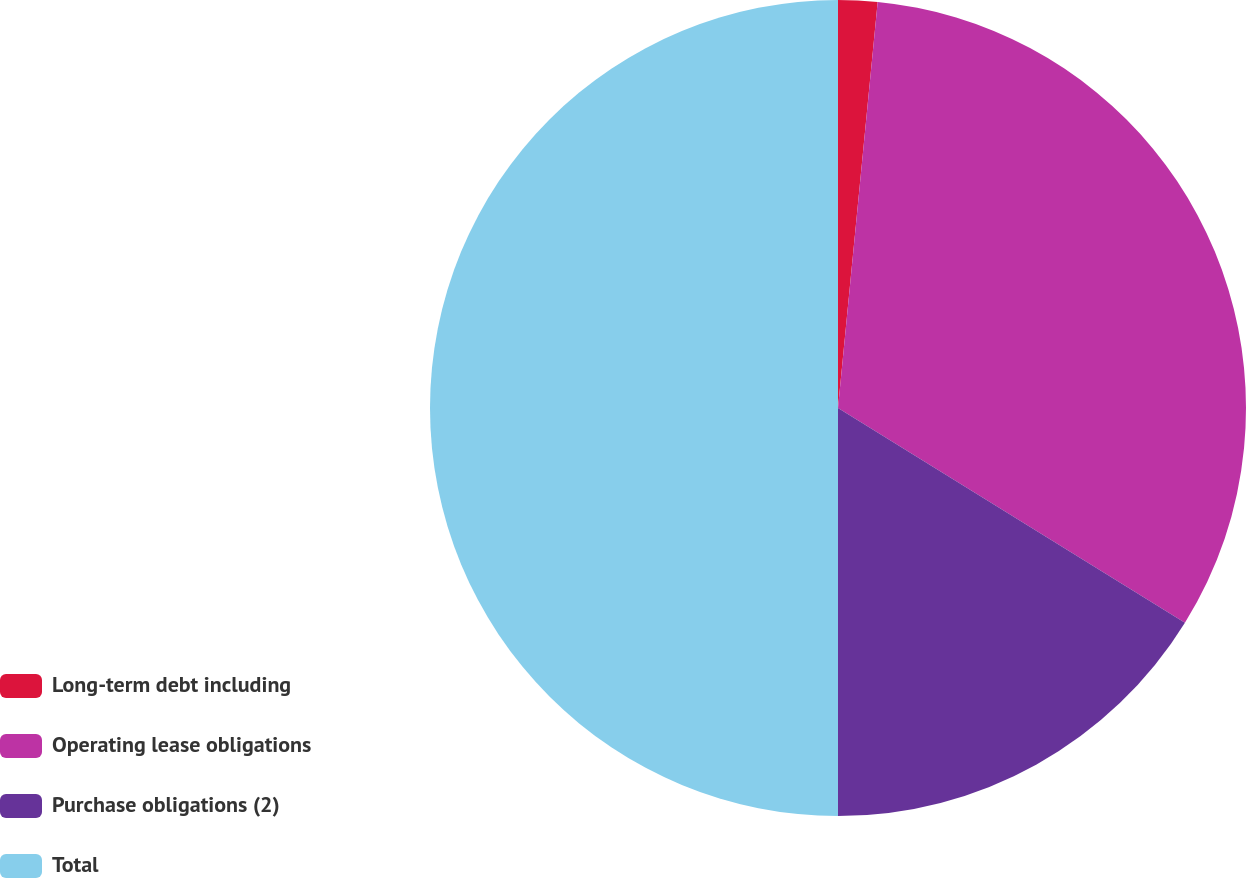Convert chart. <chart><loc_0><loc_0><loc_500><loc_500><pie_chart><fcel>Long-term debt including<fcel>Operating lease obligations<fcel>Purchase obligations (2)<fcel>Total<nl><fcel>1.55%<fcel>32.27%<fcel>16.18%<fcel>50.0%<nl></chart> 